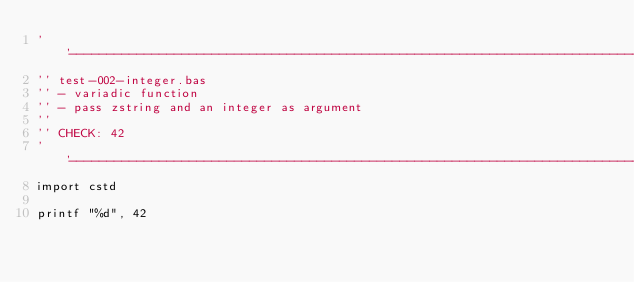<code> <loc_0><loc_0><loc_500><loc_500><_VisualBasic_>''------------------------------------------------------------------------------
'' test-002-integer.bas
'' - variadic function
'' - pass zstring and an integer as argument
''
'' CHECK: 42
''------------------------------------------------------------------------------
import cstd

printf "%d", 42
</code> 